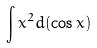Convert formula to latex. <formula><loc_0><loc_0><loc_500><loc_500>\int x ^ { 2 } d ( \cos x )</formula> 